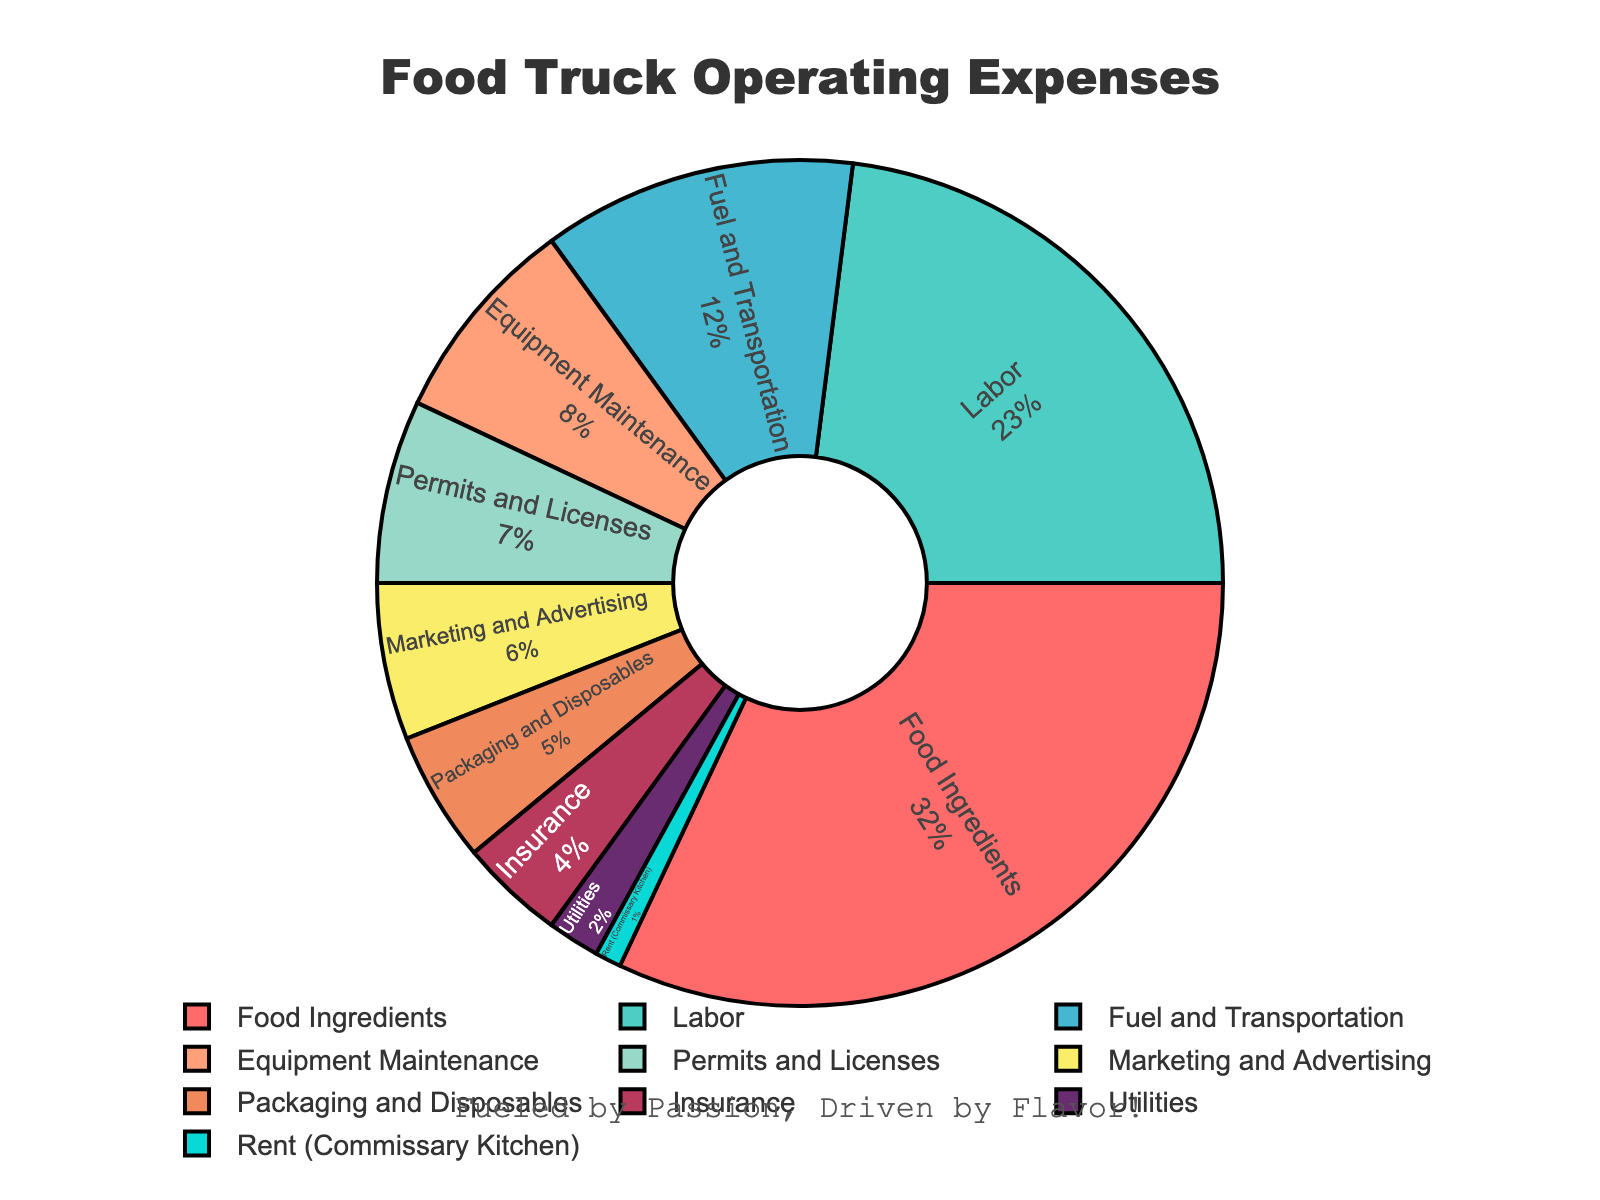What percentage of operating expenses is allocated to food ingredients and labor combined? Food ingredients account for 32% and labor accounts for 23%. Combining these percentages: 32% + 23% = 55%.
Answer: 55% Which category has a larger percentage allocation: fuel and transportation or permits and licenses? Fuel and transportation is allocated 12%, while permits and licenses are allocated 7%. Since 12% is greater than 7%, fuel and transportation has a larger percentage allocation.
Answer: Fuel and transportation How much more is spent on food ingredients than on equipment maintenance? Food ingredients are allocated 32%, and equipment maintenance is allocated 8%. The difference between these percentages is 32% - 8% = 24%.
Answer: 24% What are the three smallest categories by percentage? From the pie chart, the smallest categories by percentage are rent (commissary kitchen) at 1%, utilities at 2%, and insurance at 4%.
Answer: Rent (commissary kitchen), utilities, insurance How does the allocation for marketing and advertising compare visually to packaging and disposables? Marketing and advertising (6%) appears slightly larger than packaging and disposables (5%) on the pie chart, indicating a modestly higher allocation.
Answer: Slightly larger What percentage of total expenditures do insurance, utilities, and rent (commissary kitchen) categories collectively contribute? Insurance is 4%, utilities are 2%, and rent (commissary kitchen) is 1%. Combining these percentages: 4% + 2% + 1% = 7%.
Answer: 7% By what ratio is the allocation for food ingredients larger than for marketing and advertising? Food ingredients have a 32% allocation while marketing and advertising have a 6% allocation. Dividing these: 32% / 6% = 5.33, so the ratio is approximately 5.33:1.
Answer: 5.33:1 Is the allocation for fuel and transportation more or less than half the allocation for labor? Labor is allocated 23% and fuel and transportation is allocated 12%. Half of the labor's allocation is 23% / 2 = 11.5%. Since 12% is slightly more than 11.5%, fuel and transportation is just slightly more than half of labor's allocation.
Answer: More 